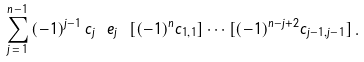Convert formula to latex. <formula><loc_0><loc_0><loc_500><loc_500>\sum _ { j \, = \, 1 } ^ { n - 1 } \, ( - 1 ) ^ { j - 1 } \, \tilde { c } _ { j } \ e _ { j } \ [ ( - 1 ) ^ { n } c _ { 1 , 1 } ] \cdots [ ( - 1 ) ^ { n - j + 2 } c _ { j - 1 , j - 1 } ] \, .</formula> 